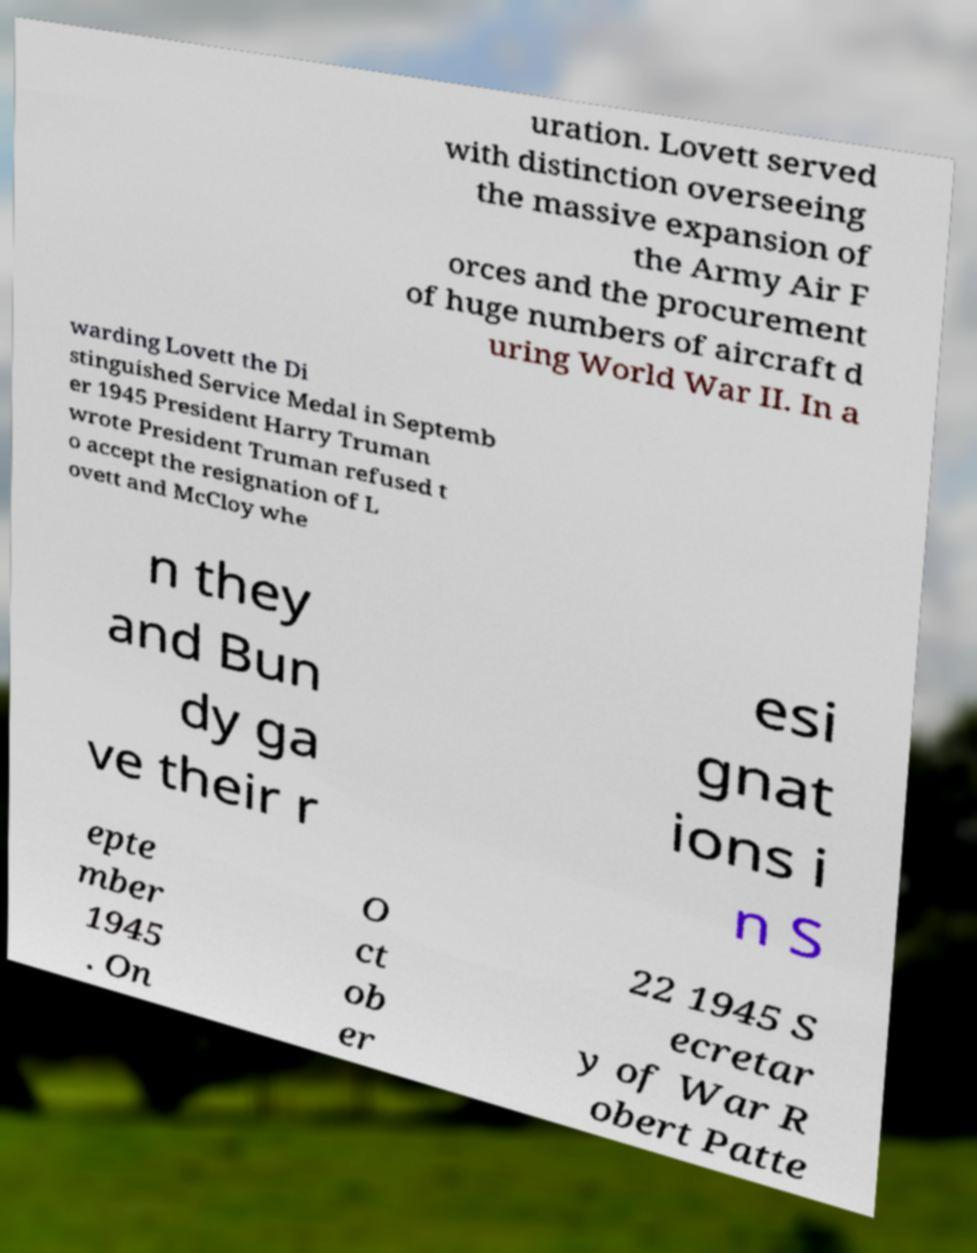I need the written content from this picture converted into text. Can you do that? uration. Lovett served with distinction overseeing the massive expansion of the Army Air F orces and the procurement of huge numbers of aircraft d uring World War II. In a warding Lovett the Di stinguished Service Medal in Septemb er 1945 President Harry Truman wrote President Truman refused t o accept the resignation of L ovett and McCloy whe n they and Bun dy ga ve their r esi gnat ions i n S epte mber 1945 . On O ct ob er 22 1945 S ecretar y of War R obert Patte 